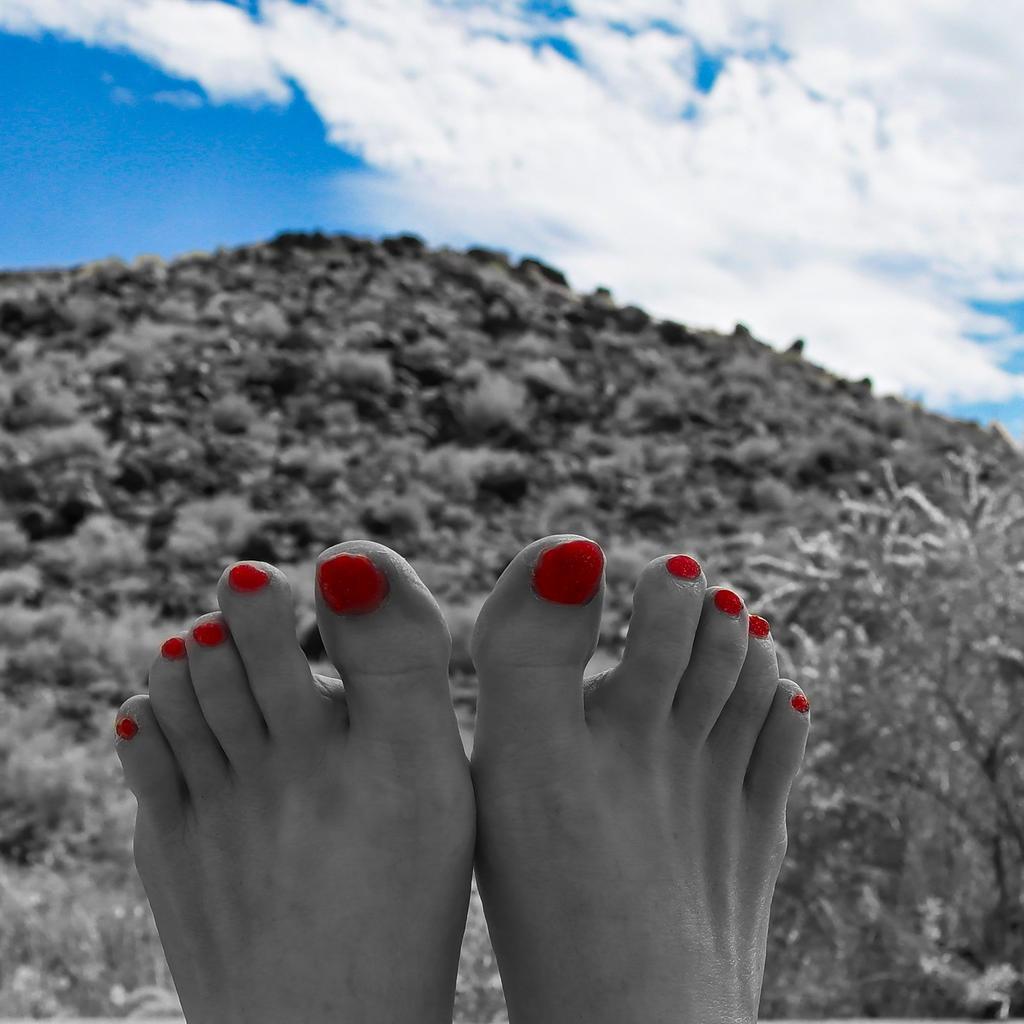Could you give a brief overview of what you see in this image? In this picture there is a close view of the girl legs with red color nail polish on the nail. Behind there is a mountain with some grass. On the top we can see sky and clouds. 